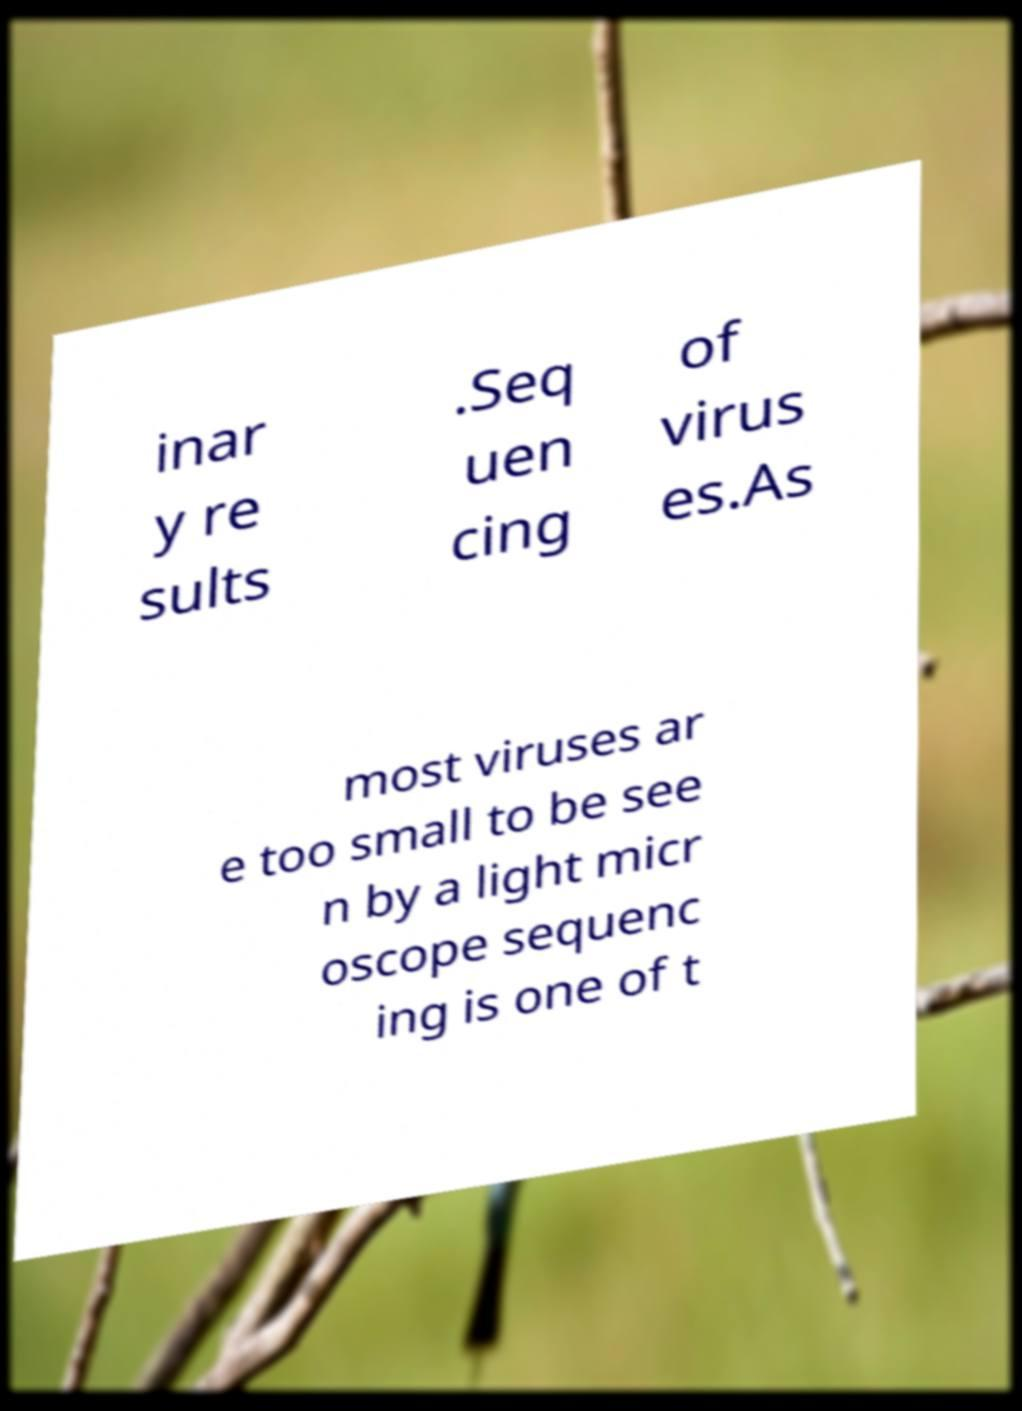I need the written content from this picture converted into text. Can you do that? inar y re sults .Seq uen cing of virus es.As most viruses ar e too small to be see n by a light micr oscope sequenc ing is one of t 